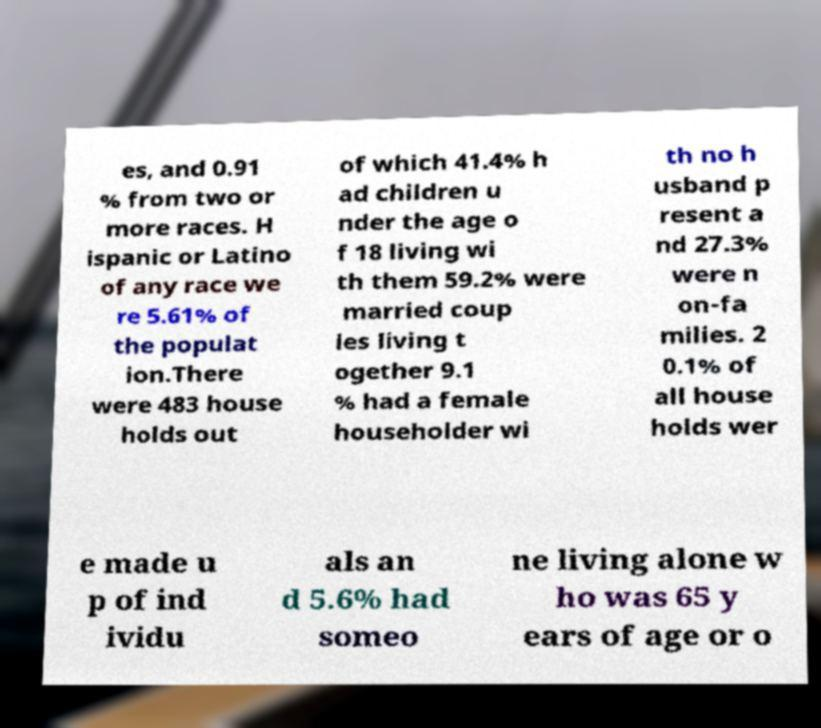What messages or text are displayed in this image? I need them in a readable, typed format. es, and 0.91 % from two or more races. H ispanic or Latino of any race we re 5.61% of the populat ion.There were 483 house holds out of which 41.4% h ad children u nder the age o f 18 living wi th them 59.2% were married coup les living t ogether 9.1 % had a female householder wi th no h usband p resent a nd 27.3% were n on-fa milies. 2 0.1% of all house holds wer e made u p of ind ividu als an d 5.6% had someo ne living alone w ho was 65 y ears of age or o 